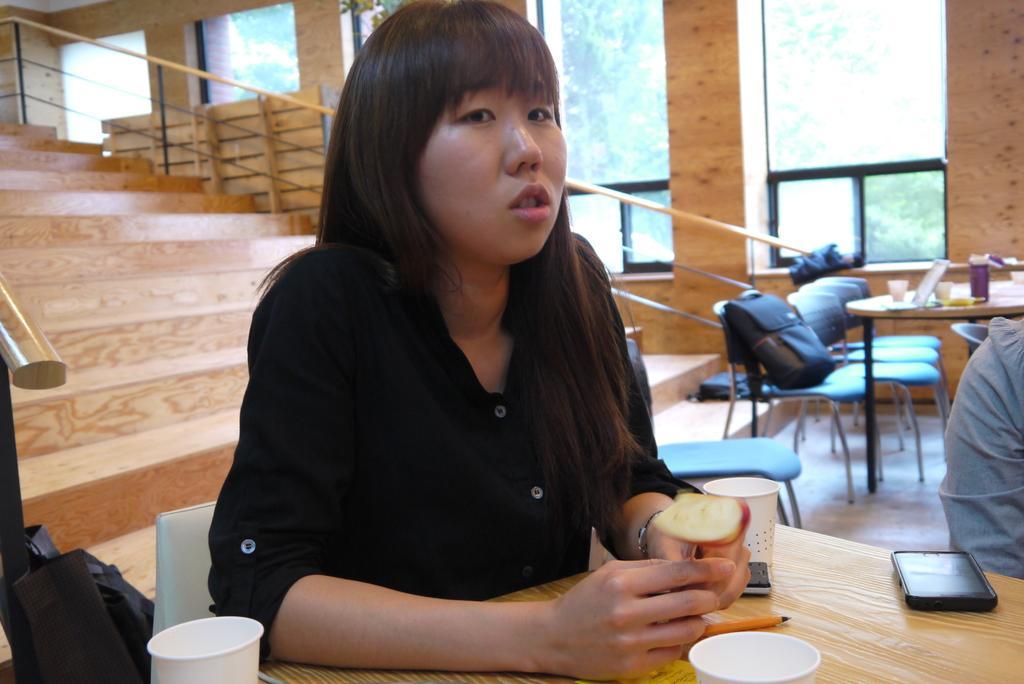Please provide a concise description of this image. In this picture we can see woman holding fruit in her hand and in front of her on table we have glasses, mobile, pen where she is sitting on chair and in background we can see steps, fence, wall, windows, bag on chair. 